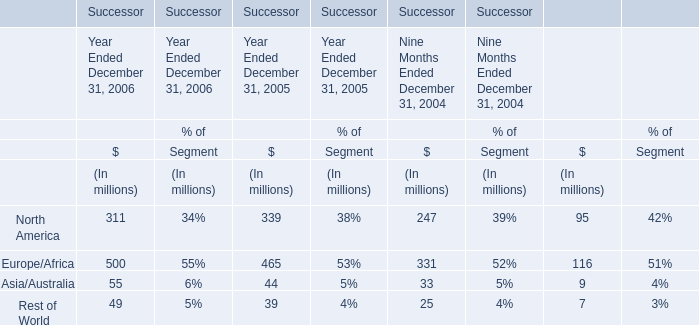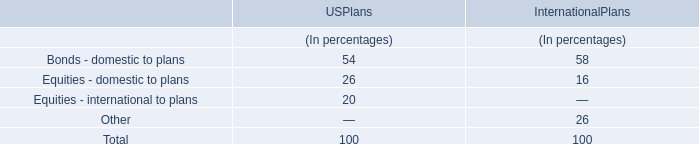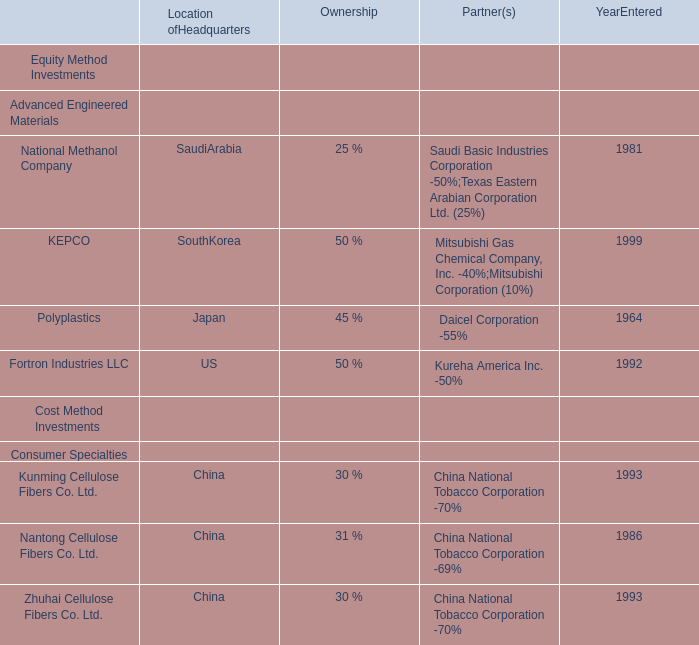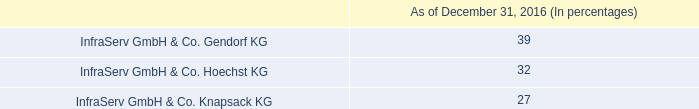Which Sales occupies the greatest proportion in total amount (in 2006)? 
Answer: Europe/Africa. 